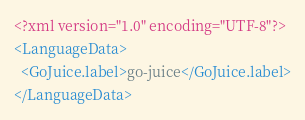<code> <loc_0><loc_0><loc_500><loc_500><_XML_><?xml version="1.0" encoding="UTF-8"?>
<LanguageData>
  <GoJuice.label>go-juice</GoJuice.label>
</LanguageData></code> 